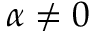Convert formula to latex. <formula><loc_0><loc_0><loc_500><loc_500>\alpha \neq 0</formula> 